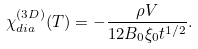Convert formula to latex. <formula><loc_0><loc_0><loc_500><loc_500>\chi _ { d i a } ^ { ( 3 D ) } ( T ) = - \frac { \rho V } { 1 2 B _ { 0 } \xi _ { 0 } t ^ { 1 / 2 } } .</formula> 